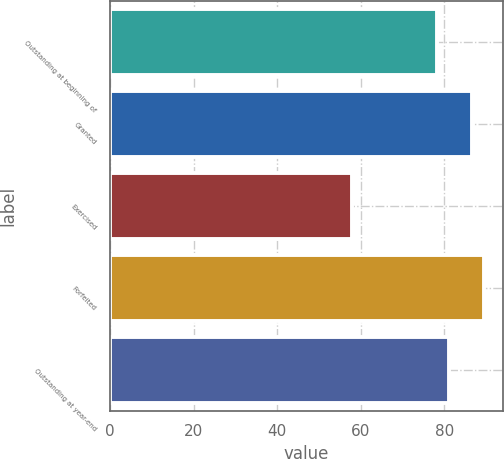Convert chart to OTSL. <chart><loc_0><loc_0><loc_500><loc_500><bar_chart><fcel>Outstanding at beginning of<fcel>Granted<fcel>Exercised<fcel>Forfeited<fcel>Outstanding at year-end<nl><fcel>78.31<fcel>86.55<fcel>57.87<fcel>89.46<fcel>81.22<nl></chart> 